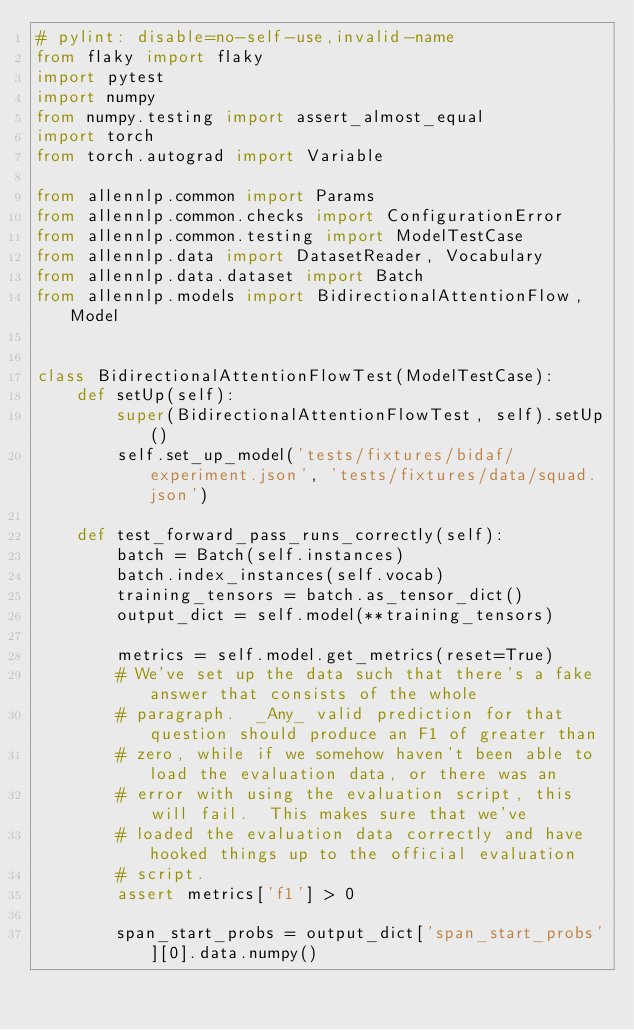<code> <loc_0><loc_0><loc_500><loc_500><_Python_># pylint: disable=no-self-use,invalid-name
from flaky import flaky
import pytest
import numpy
from numpy.testing import assert_almost_equal
import torch
from torch.autograd import Variable

from allennlp.common import Params
from allennlp.common.checks import ConfigurationError
from allennlp.common.testing import ModelTestCase
from allennlp.data import DatasetReader, Vocabulary
from allennlp.data.dataset import Batch
from allennlp.models import BidirectionalAttentionFlow, Model


class BidirectionalAttentionFlowTest(ModelTestCase):
    def setUp(self):
        super(BidirectionalAttentionFlowTest, self).setUp()
        self.set_up_model('tests/fixtures/bidaf/experiment.json', 'tests/fixtures/data/squad.json')

    def test_forward_pass_runs_correctly(self):
        batch = Batch(self.instances)
        batch.index_instances(self.vocab)
        training_tensors = batch.as_tensor_dict()
        output_dict = self.model(**training_tensors)

        metrics = self.model.get_metrics(reset=True)
        # We've set up the data such that there's a fake answer that consists of the whole
        # paragraph.  _Any_ valid prediction for that question should produce an F1 of greater than
        # zero, while if we somehow haven't been able to load the evaluation data, or there was an
        # error with using the evaluation script, this will fail.  This makes sure that we've
        # loaded the evaluation data correctly and have hooked things up to the official evaluation
        # script.
        assert metrics['f1'] > 0

        span_start_probs = output_dict['span_start_probs'][0].data.numpy()</code> 